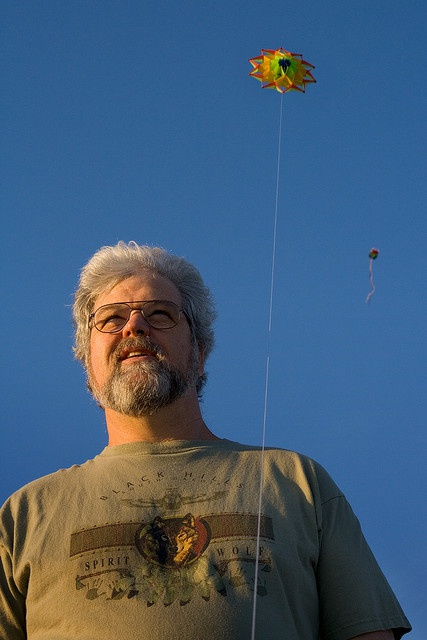Describe the objects in this image and their specific colors. I can see people in blue, black, olive, and tan tones, kite in blue, olive, and maroon tones, and kite in blue, gray, black, and maroon tones in this image. 